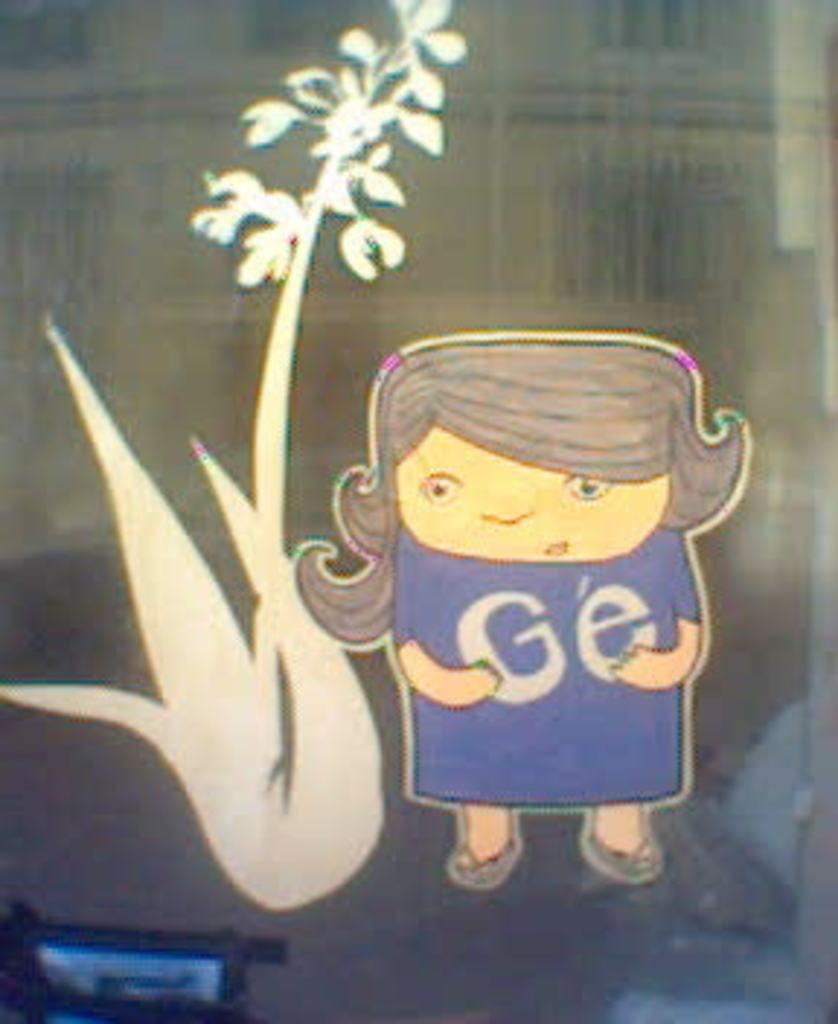What type of stickers are on the glass in the image? There is a sticker of an animated image of a person and a sticker of a plant on the glass. How close are the stickers to each other? The stickers are near each other on the glass. What else can be seen in the background of the image? There are other objects in the background. What type of government is depicted in the animated sticker? There is no government depicted in the animated sticker; it is an image of a person, not a political entity. 